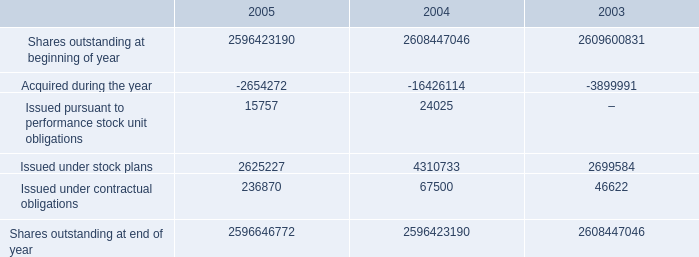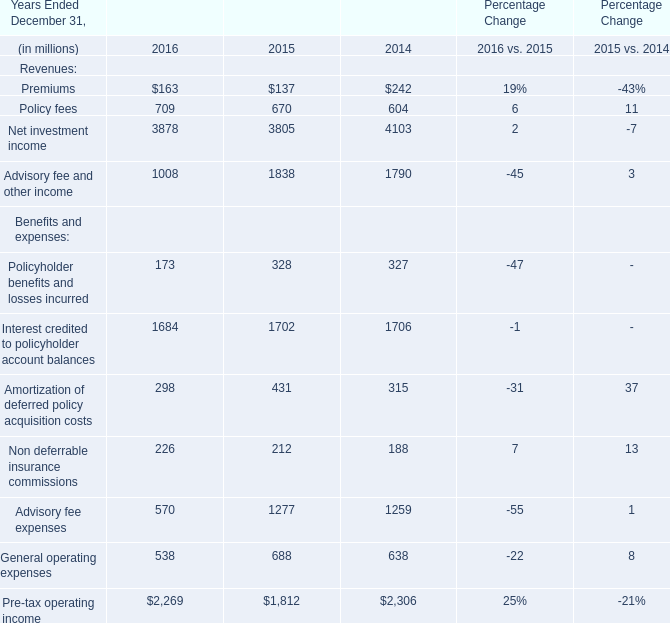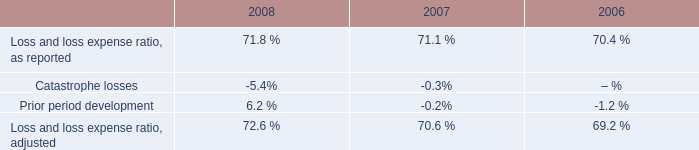What is the average amount of Net investment income of Percentage Change 2014, and Issued under stock plans of 2004 ? 
Computations: ((4103.0 + 4310733.0) / 2)
Answer: 2157418.0. 